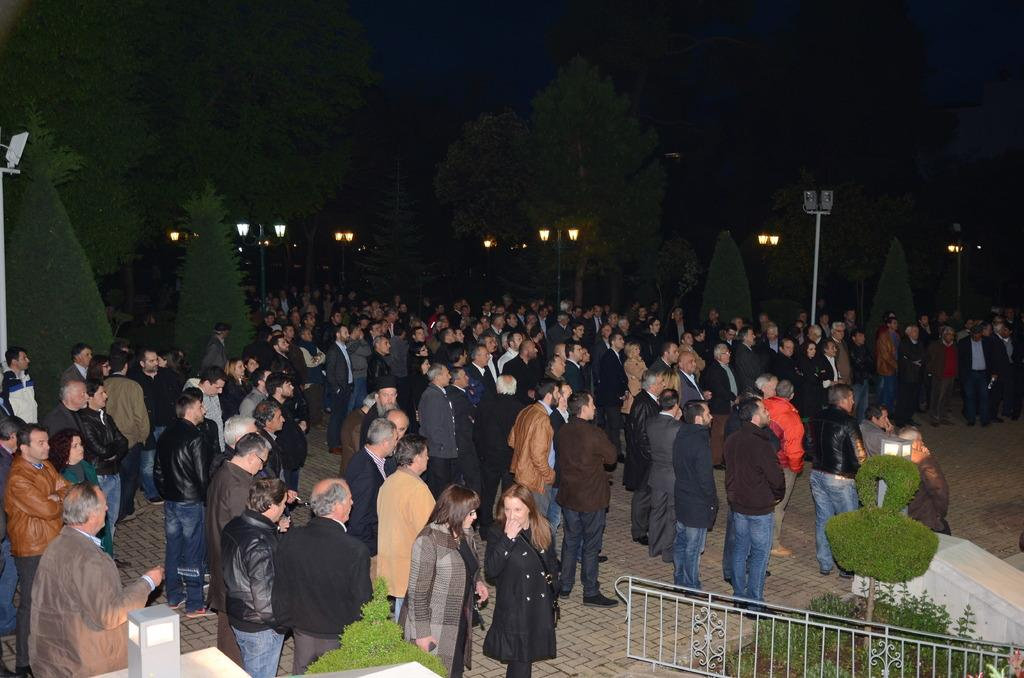What are the people in the image doing? The people in the image are standing in the center. What can be seen in the background of the image? There are light poles and trees in the background of the image. What is at the bottom of the image? There is a gate at the bottom of the image. What type of vegetation is present in the image? There are plants in the image. What time of day is it in the image, considering the presence of babies? There is no mention of babies in the image, and therefore we cannot determine the time of day based on their presence. 